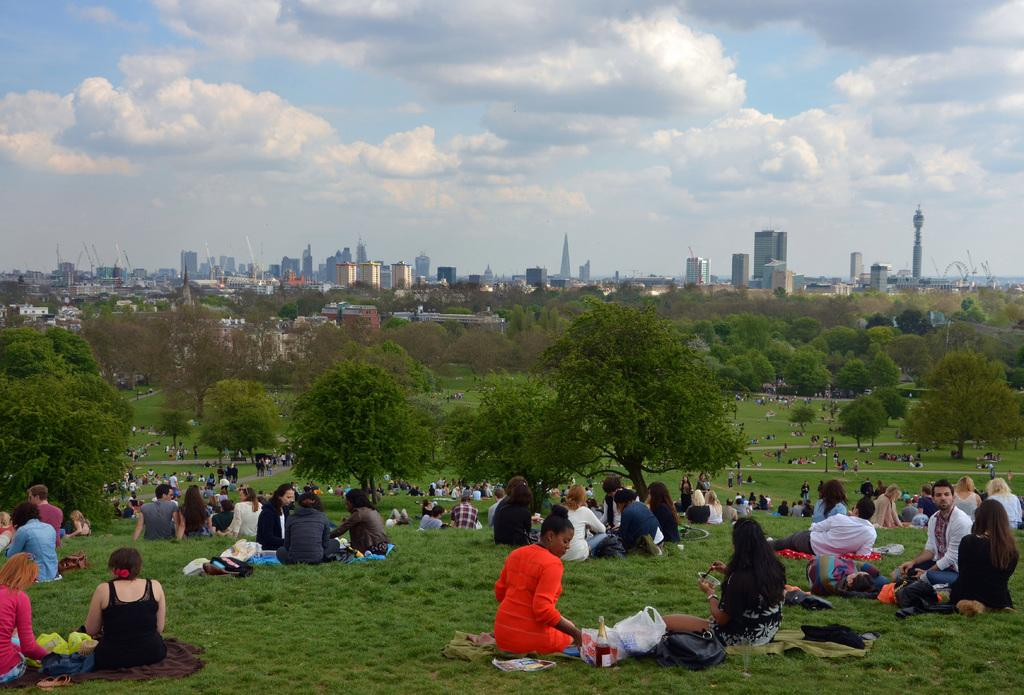What are the people in the image doing? People are sitting on the grass in the image. What items can be seen near the people? There are bags, polythene bags, and a bottle in the image. What type of vegetation is visible in the image? There are trees in the image. What type of structures can be seen in the image? There are buildings in the image. What is visible in the sky in the image? There are clouds in the sky in the image. What type of hat is the baby wearing in the crib in the image? There is no baby or crib present in the image; it features people sitting on the grass with bags, polythene bags, a bottle, trees, buildings, and clouds in the sky. 